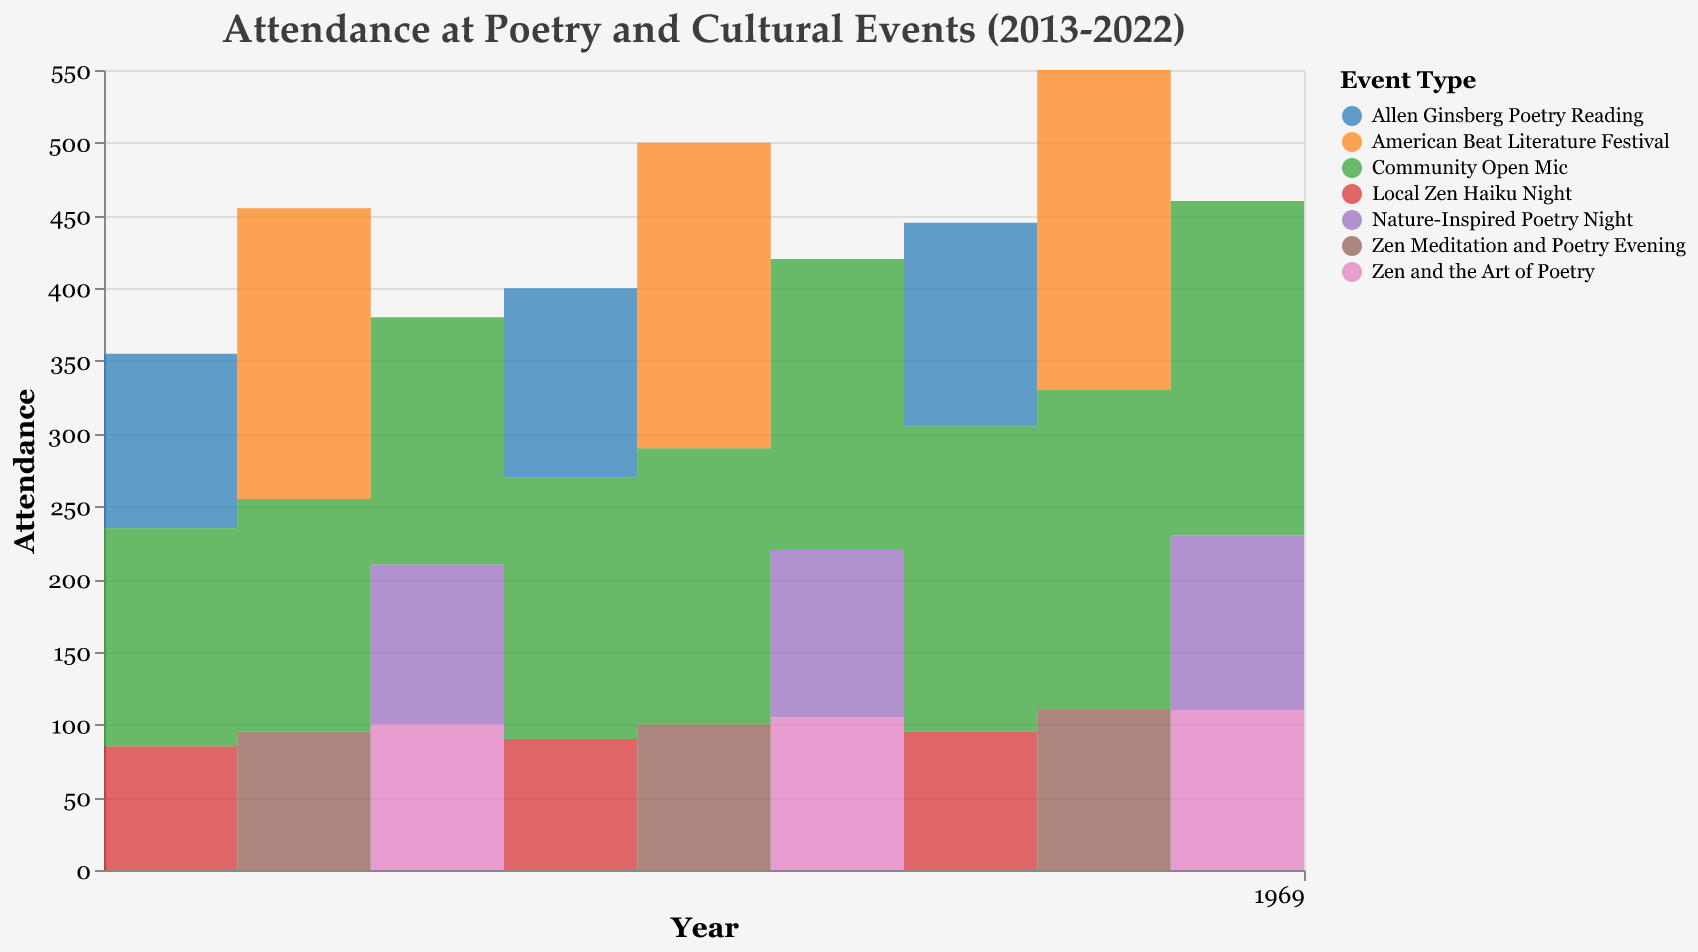What's the title of the chart? Look at the top section of the figure where the title is displayed. The title is usually a complete descriptive text explaining what the chart represents.
Answer: Attendance at Poetry and Cultural Events (2013-2022) How many types of events are represented in the chart? Check the legend section of the chart that lists all event types based on their color-coding. Count the number of distinct event types.
Answer: 6 In which year did the "Community Open Mic" have the highest attendance? Identify the "Community Open Mic" event in the legend to know its color. Follow the color across the step area chart to find the year where the attendance was at its peak.
Answer: 2022 What is the trend of attendance for the "Allen Ginsberg Poetry Reading" from 2013 to 2022? Identify the color for "Allen Ginsberg Poetry Reading" from the legend and track its step changes along the x-axis (Years) to describe whether attendance is increasing, decreasing, or fluctuating.
Answer: Increasing Which event had the highest overall attendance in 2020? Observe the y-axis (Attendance) and locate the peak attendance values for each event in 2020. Compare the values to determine the highest one.
Answer: American Beat Literature Festival How does the attendance of "Local Zen Haiku Night" in 2019 compare to that in 2022? Identify the attendance for "Local Zen Haiku Night" in 2019 and 2022 from the chart and compare the two values to see if there's an increase or decrease.
Answer: Decreased from 95 in 2019 to 100 in 2022 What can you infer about the popularity of "Community Open Mic" over the decade? Track the attendance of "Community Open Mic" year by year to conclude if it shows an upward or downward trend, or consistent attendance over time.
Answer: Increasing steadily Which event showed the least variation in attendance over the years? Examine the attendance ranges of all events from the lowest to the highest value and identify which event has the smallest range.
Answer: Local Zen Haiku Night 